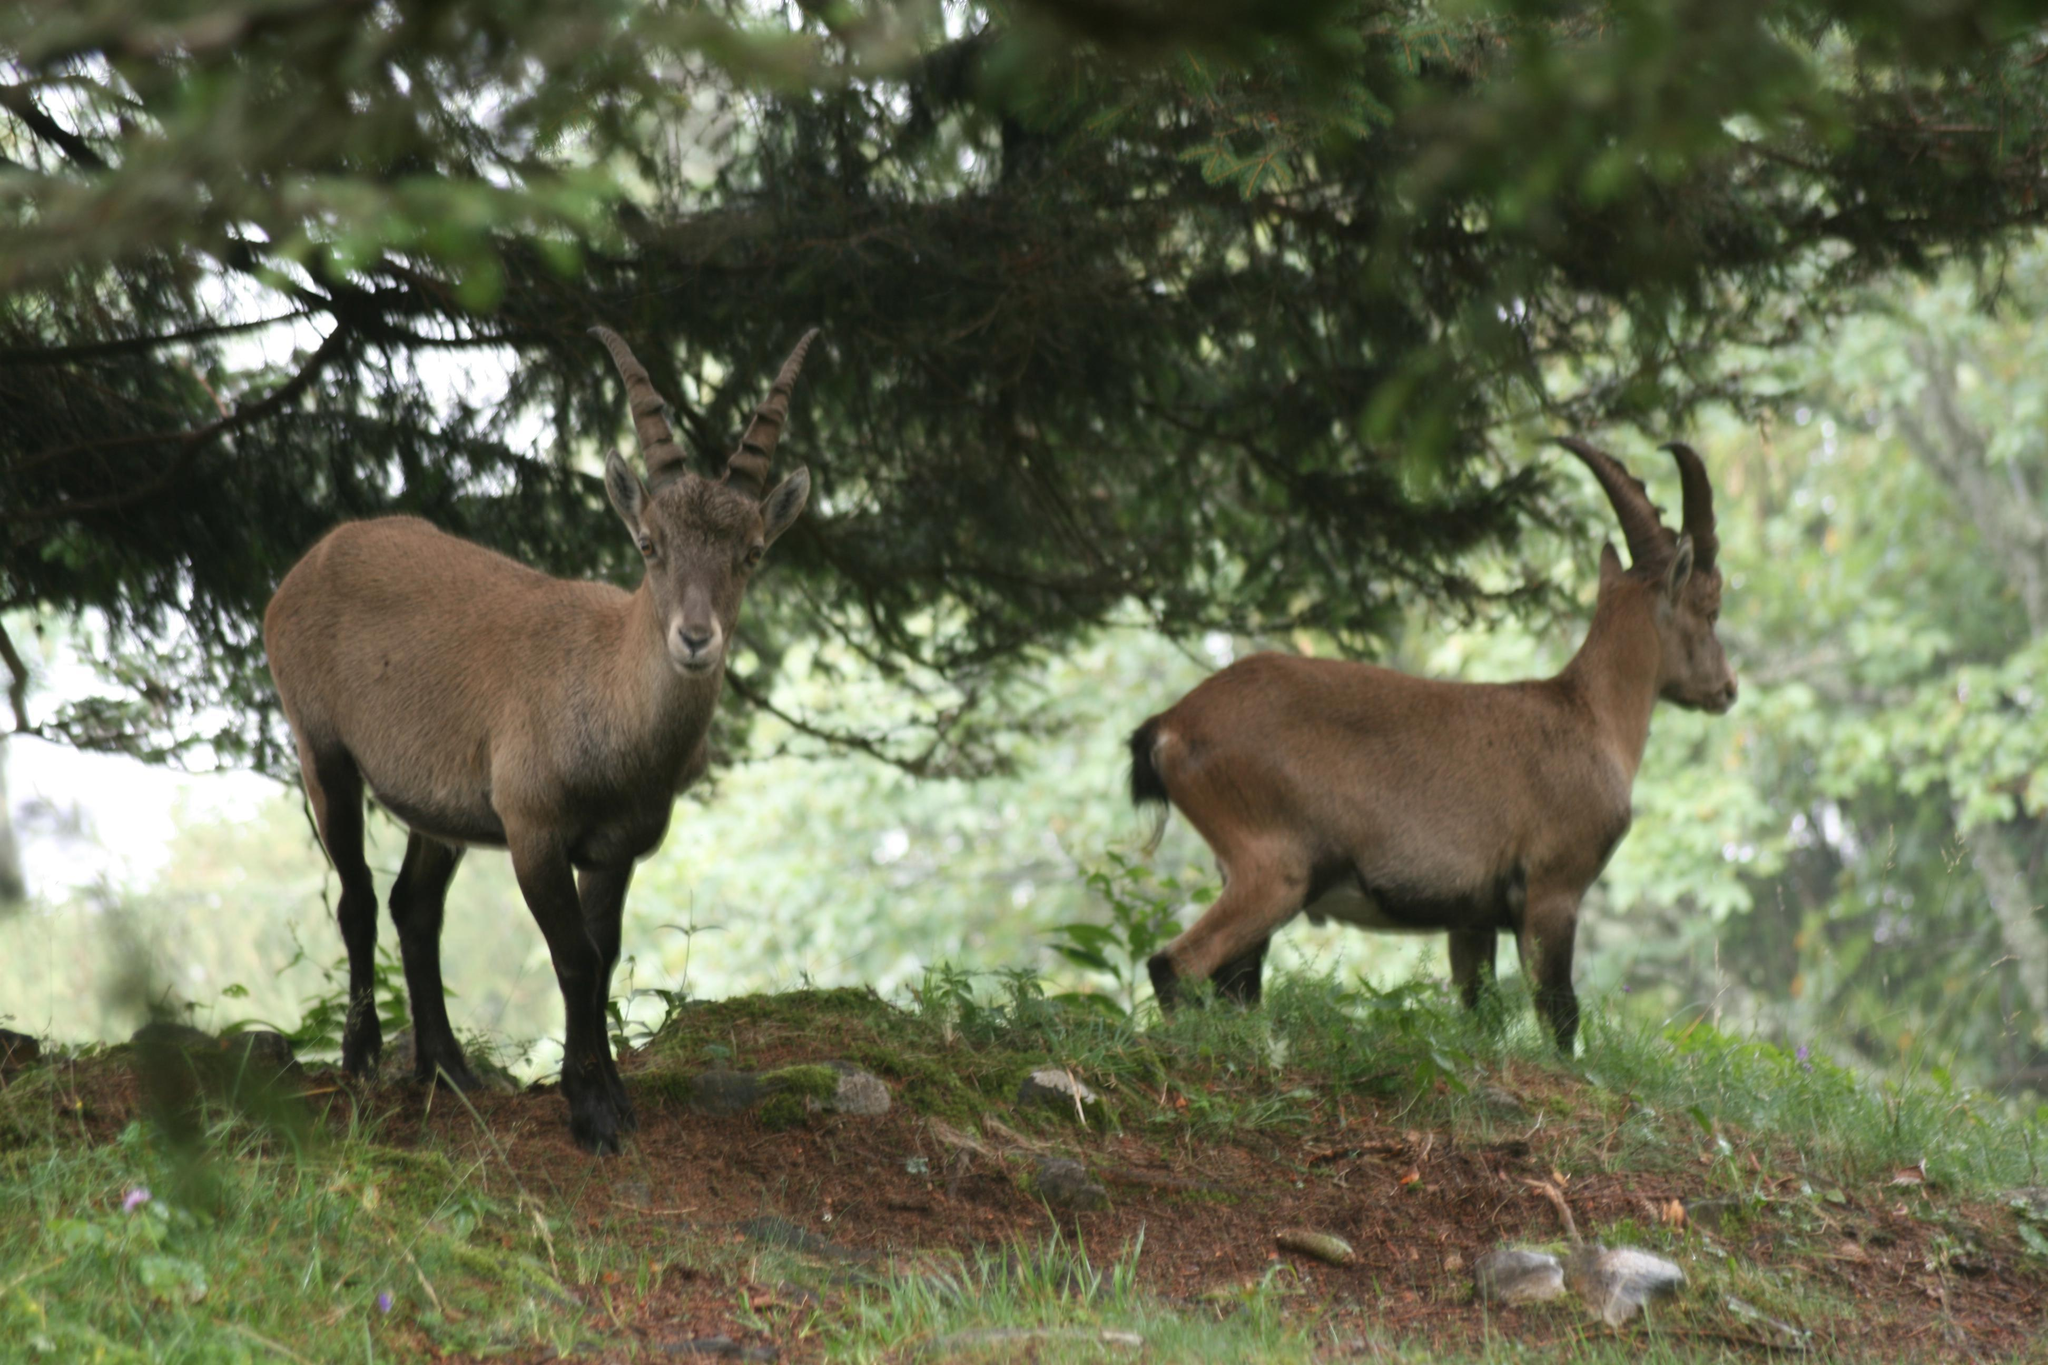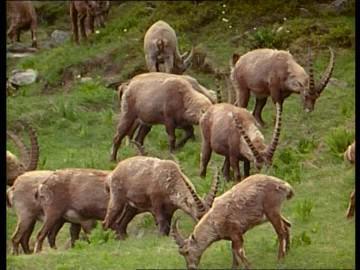The first image is the image on the left, the second image is the image on the right. Considering the images on both sides, is "The left image shows two animals standing under a tree." valid? Answer yes or no. Yes. The first image is the image on the left, the second image is the image on the right. Analyze the images presented: Is the assertion "The right image includes at least twice the number of horned animals as the left image." valid? Answer yes or no. Yes. 